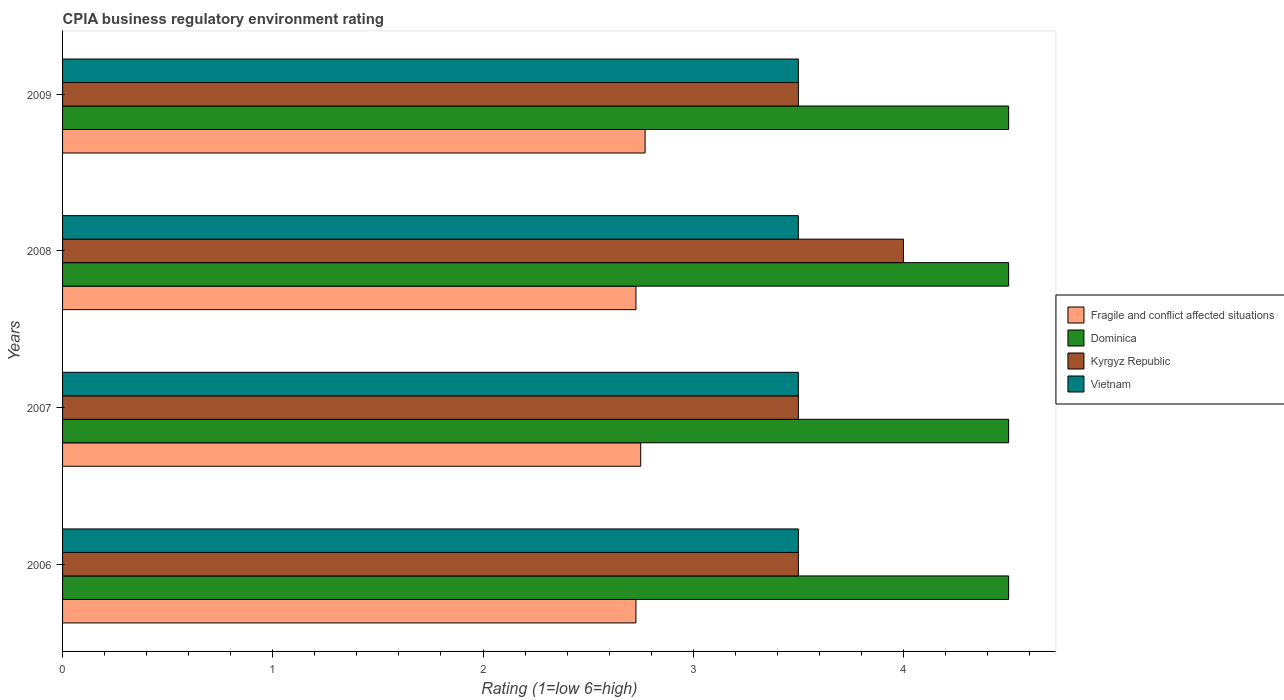How many different coloured bars are there?
Your answer should be compact. 4. Are the number of bars per tick equal to the number of legend labels?
Ensure brevity in your answer.  Yes. In how many cases, is the number of bars for a given year not equal to the number of legend labels?
Offer a terse response. 0. Across all years, what is the maximum CPIA rating in Kyrgyz Republic?
Give a very brief answer. 4. What is the total CPIA rating in Kyrgyz Republic in the graph?
Provide a succinct answer. 14.5. What is the average CPIA rating in Dominica per year?
Give a very brief answer. 4.5. What is the ratio of the CPIA rating in Kyrgyz Republic in 2006 to that in 2008?
Keep it short and to the point. 0.88. Is the CPIA rating in Kyrgyz Republic in 2006 less than that in 2007?
Your answer should be very brief. No. Is the difference between the CPIA rating in Kyrgyz Republic in 2006 and 2009 greater than the difference between the CPIA rating in Dominica in 2006 and 2009?
Keep it short and to the point. No. Is it the case that in every year, the sum of the CPIA rating in Kyrgyz Republic and CPIA rating in Vietnam is greater than the sum of CPIA rating in Dominica and CPIA rating in Fragile and conflict affected situations?
Make the answer very short. No. What does the 4th bar from the top in 2008 represents?
Make the answer very short. Fragile and conflict affected situations. What does the 2nd bar from the bottom in 2008 represents?
Provide a succinct answer. Dominica. How many bars are there?
Provide a short and direct response. 16. Are the values on the major ticks of X-axis written in scientific E-notation?
Provide a short and direct response. No. Does the graph contain any zero values?
Give a very brief answer. No. Does the graph contain grids?
Provide a short and direct response. No. Where does the legend appear in the graph?
Give a very brief answer. Center right. How many legend labels are there?
Offer a very short reply. 4. How are the legend labels stacked?
Ensure brevity in your answer.  Vertical. What is the title of the graph?
Provide a succinct answer. CPIA business regulatory environment rating. What is the label or title of the X-axis?
Give a very brief answer. Rating (1=low 6=high). What is the label or title of the Y-axis?
Keep it short and to the point. Years. What is the Rating (1=low 6=high) in Fragile and conflict affected situations in 2006?
Your answer should be compact. 2.73. What is the Rating (1=low 6=high) in Kyrgyz Republic in 2006?
Your response must be concise. 3.5. What is the Rating (1=low 6=high) in Fragile and conflict affected situations in 2007?
Your response must be concise. 2.75. What is the Rating (1=low 6=high) of Kyrgyz Republic in 2007?
Offer a very short reply. 3.5. What is the Rating (1=low 6=high) of Vietnam in 2007?
Offer a very short reply. 3.5. What is the Rating (1=low 6=high) of Fragile and conflict affected situations in 2008?
Your answer should be compact. 2.73. What is the Rating (1=low 6=high) of Vietnam in 2008?
Provide a short and direct response. 3.5. What is the Rating (1=low 6=high) in Fragile and conflict affected situations in 2009?
Offer a very short reply. 2.77. What is the Rating (1=low 6=high) in Dominica in 2009?
Your response must be concise. 4.5. What is the Rating (1=low 6=high) in Kyrgyz Republic in 2009?
Your response must be concise. 3.5. What is the Rating (1=low 6=high) in Vietnam in 2009?
Provide a short and direct response. 3.5. Across all years, what is the maximum Rating (1=low 6=high) in Fragile and conflict affected situations?
Offer a terse response. 2.77. Across all years, what is the maximum Rating (1=low 6=high) of Vietnam?
Give a very brief answer. 3.5. Across all years, what is the minimum Rating (1=low 6=high) of Fragile and conflict affected situations?
Give a very brief answer. 2.73. Across all years, what is the minimum Rating (1=low 6=high) in Dominica?
Your answer should be compact. 4.5. Across all years, what is the minimum Rating (1=low 6=high) of Kyrgyz Republic?
Provide a short and direct response. 3.5. Across all years, what is the minimum Rating (1=low 6=high) in Vietnam?
Offer a very short reply. 3.5. What is the total Rating (1=low 6=high) in Fragile and conflict affected situations in the graph?
Ensure brevity in your answer.  10.98. What is the total Rating (1=low 6=high) of Kyrgyz Republic in the graph?
Give a very brief answer. 14.5. What is the difference between the Rating (1=low 6=high) of Fragile and conflict affected situations in 2006 and that in 2007?
Your response must be concise. -0.02. What is the difference between the Rating (1=low 6=high) in Fragile and conflict affected situations in 2006 and that in 2008?
Your answer should be very brief. 0. What is the difference between the Rating (1=low 6=high) in Dominica in 2006 and that in 2008?
Your answer should be very brief. 0. What is the difference between the Rating (1=low 6=high) in Fragile and conflict affected situations in 2006 and that in 2009?
Make the answer very short. -0.04. What is the difference between the Rating (1=low 6=high) of Kyrgyz Republic in 2006 and that in 2009?
Offer a terse response. 0. What is the difference between the Rating (1=low 6=high) in Fragile and conflict affected situations in 2007 and that in 2008?
Your response must be concise. 0.02. What is the difference between the Rating (1=low 6=high) of Kyrgyz Republic in 2007 and that in 2008?
Keep it short and to the point. -0.5. What is the difference between the Rating (1=low 6=high) in Vietnam in 2007 and that in 2008?
Your answer should be very brief. 0. What is the difference between the Rating (1=low 6=high) in Fragile and conflict affected situations in 2007 and that in 2009?
Your answer should be compact. -0.02. What is the difference between the Rating (1=low 6=high) in Dominica in 2007 and that in 2009?
Ensure brevity in your answer.  0. What is the difference between the Rating (1=low 6=high) in Fragile and conflict affected situations in 2008 and that in 2009?
Make the answer very short. -0.04. What is the difference between the Rating (1=low 6=high) in Kyrgyz Republic in 2008 and that in 2009?
Provide a short and direct response. 0.5. What is the difference between the Rating (1=low 6=high) of Vietnam in 2008 and that in 2009?
Make the answer very short. 0. What is the difference between the Rating (1=low 6=high) of Fragile and conflict affected situations in 2006 and the Rating (1=low 6=high) of Dominica in 2007?
Give a very brief answer. -1.77. What is the difference between the Rating (1=low 6=high) of Fragile and conflict affected situations in 2006 and the Rating (1=low 6=high) of Kyrgyz Republic in 2007?
Your answer should be very brief. -0.77. What is the difference between the Rating (1=low 6=high) in Fragile and conflict affected situations in 2006 and the Rating (1=low 6=high) in Vietnam in 2007?
Offer a terse response. -0.77. What is the difference between the Rating (1=low 6=high) in Dominica in 2006 and the Rating (1=low 6=high) in Kyrgyz Republic in 2007?
Provide a succinct answer. 1. What is the difference between the Rating (1=low 6=high) in Dominica in 2006 and the Rating (1=low 6=high) in Vietnam in 2007?
Offer a very short reply. 1. What is the difference between the Rating (1=low 6=high) of Kyrgyz Republic in 2006 and the Rating (1=low 6=high) of Vietnam in 2007?
Your answer should be compact. 0. What is the difference between the Rating (1=low 6=high) in Fragile and conflict affected situations in 2006 and the Rating (1=low 6=high) in Dominica in 2008?
Ensure brevity in your answer.  -1.77. What is the difference between the Rating (1=low 6=high) of Fragile and conflict affected situations in 2006 and the Rating (1=low 6=high) of Kyrgyz Republic in 2008?
Ensure brevity in your answer.  -1.27. What is the difference between the Rating (1=low 6=high) of Fragile and conflict affected situations in 2006 and the Rating (1=low 6=high) of Vietnam in 2008?
Your answer should be very brief. -0.77. What is the difference between the Rating (1=low 6=high) in Dominica in 2006 and the Rating (1=low 6=high) in Kyrgyz Republic in 2008?
Provide a succinct answer. 0.5. What is the difference between the Rating (1=low 6=high) in Dominica in 2006 and the Rating (1=low 6=high) in Vietnam in 2008?
Ensure brevity in your answer.  1. What is the difference between the Rating (1=low 6=high) of Kyrgyz Republic in 2006 and the Rating (1=low 6=high) of Vietnam in 2008?
Make the answer very short. 0. What is the difference between the Rating (1=low 6=high) in Fragile and conflict affected situations in 2006 and the Rating (1=low 6=high) in Dominica in 2009?
Provide a succinct answer. -1.77. What is the difference between the Rating (1=low 6=high) in Fragile and conflict affected situations in 2006 and the Rating (1=low 6=high) in Kyrgyz Republic in 2009?
Your answer should be compact. -0.77. What is the difference between the Rating (1=low 6=high) in Fragile and conflict affected situations in 2006 and the Rating (1=low 6=high) in Vietnam in 2009?
Offer a very short reply. -0.77. What is the difference between the Rating (1=low 6=high) in Dominica in 2006 and the Rating (1=low 6=high) in Kyrgyz Republic in 2009?
Make the answer very short. 1. What is the difference between the Rating (1=low 6=high) of Fragile and conflict affected situations in 2007 and the Rating (1=low 6=high) of Dominica in 2008?
Your answer should be very brief. -1.75. What is the difference between the Rating (1=low 6=high) in Fragile and conflict affected situations in 2007 and the Rating (1=low 6=high) in Kyrgyz Republic in 2008?
Make the answer very short. -1.25. What is the difference between the Rating (1=low 6=high) in Fragile and conflict affected situations in 2007 and the Rating (1=low 6=high) in Vietnam in 2008?
Your response must be concise. -0.75. What is the difference between the Rating (1=low 6=high) of Dominica in 2007 and the Rating (1=low 6=high) of Vietnam in 2008?
Your response must be concise. 1. What is the difference between the Rating (1=low 6=high) of Kyrgyz Republic in 2007 and the Rating (1=low 6=high) of Vietnam in 2008?
Offer a terse response. 0. What is the difference between the Rating (1=low 6=high) of Fragile and conflict affected situations in 2007 and the Rating (1=low 6=high) of Dominica in 2009?
Your answer should be very brief. -1.75. What is the difference between the Rating (1=low 6=high) in Fragile and conflict affected situations in 2007 and the Rating (1=low 6=high) in Kyrgyz Republic in 2009?
Make the answer very short. -0.75. What is the difference between the Rating (1=low 6=high) in Fragile and conflict affected situations in 2007 and the Rating (1=low 6=high) in Vietnam in 2009?
Keep it short and to the point. -0.75. What is the difference between the Rating (1=low 6=high) in Dominica in 2007 and the Rating (1=low 6=high) in Vietnam in 2009?
Your answer should be compact. 1. What is the difference between the Rating (1=low 6=high) in Kyrgyz Republic in 2007 and the Rating (1=low 6=high) in Vietnam in 2009?
Offer a very short reply. 0. What is the difference between the Rating (1=low 6=high) of Fragile and conflict affected situations in 2008 and the Rating (1=low 6=high) of Dominica in 2009?
Ensure brevity in your answer.  -1.77. What is the difference between the Rating (1=low 6=high) in Fragile and conflict affected situations in 2008 and the Rating (1=low 6=high) in Kyrgyz Republic in 2009?
Your response must be concise. -0.77. What is the difference between the Rating (1=low 6=high) of Fragile and conflict affected situations in 2008 and the Rating (1=low 6=high) of Vietnam in 2009?
Keep it short and to the point. -0.77. What is the difference between the Rating (1=low 6=high) in Kyrgyz Republic in 2008 and the Rating (1=low 6=high) in Vietnam in 2009?
Your answer should be compact. 0.5. What is the average Rating (1=low 6=high) of Fragile and conflict affected situations per year?
Keep it short and to the point. 2.74. What is the average Rating (1=low 6=high) of Kyrgyz Republic per year?
Ensure brevity in your answer.  3.62. In the year 2006, what is the difference between the Rating (1=low 6=high) in Fragile and conflict affected situations and Rating (1=low 6=high) in Dominica?
Offer a terse response. -1.77. In the year 2006, what is the difference between the Rating (1=low 6=high) of Fragile and conflict affected situations and Rating (1=low 6=high) of Kyrgyz Republic?
Offer a very short reply. -0.77. In the year 2006, what is the difference between the Rating (1=low 6=high) in Fragile and conflict affected situations and Rating (1=low 6=high) in Vietnam?
Make the answer very short. -0.77. In the year 2006, what is the difference between the Rating (1=low 6=high) in Dominica and Rating (1=low 6=high) in Vietnam?
Offer a terse response. 1. In the year 2006, what is the difference between the Rating (1=low 6=high) of Kyrgyz Republic and Rating (1=low 6=high) of Vietnam?
Your response must be concise. 0. In the year 2007, what is the difference between the Rating (1=low 6=high) in Fragile and conflict affected situations and Rating (1=low 6=high) in Dominica?
Offer a terse response. -1.75. In the year 2007, what is the difference between the Rating (1=low 6=high) of Fragile and conflict affected situations and Rating (1=low 6=high) of Kyrgyz Republic?
Give a very brief answer. -0.75. In the year 2007, what is the difference between the Rating (1=low 6=high) in Fragile and conflict affected situations and Rating (1=low 6=high) in Vietnam?
Ensure brevity in your answer.  -0.75. In the year 2007, what is the difference between the Rating (1=low 6=high) of Dominica and Rating (1=low 6=high) of Kyrgyz Republic?
Provide a short and direct response. 1. In the year 2008, what is the difference between the Rating (1=low 6=high) of Fragile and conflict affected situations and Rating (1=low 6=high) of Dominica?
Offer a very short reply. -1.77. In the year 2008, what is the difference between the Rating (1=low 6=high) of Fragile and conflict affected situations and Rating (1=low 6=high) of Kyrgyz Republic?
Your answer should be compact. -1.27. In the year 2008, what is the difference between the Rating (1=low 6=high) in Fragile and conflict affected situations and Rating (1=low 6=high) in Vietnam?
Offer a terse response. -0.77. In the year 2008, what is the difference between the Rating (1=low 6=high) in Dominica and Rating (1=low 6=high) in Kyrgyz Republic?
Your answer should be very brief. 0.5. In the year 2009, what is the difference between the Rating (1=low 6=high) of Fragile and conflict affected situations and Rating (1=low 6=high) of Dominica?
Make the answer very short. -1.73. In the year 2009, what is the difference between the Rating (1=low 6=high) in Fragile and conflict affected situations and Rating (1=low 6=high) in Kyrgyz Republic?
Make the answer very short. -0.73. In the year 2009, what is the difference between the Rating (1=low 6=high) of Fragile and conflict affected situations and Rating (1=low 6=high) of Vietnam?
Provide a succinct answer. -0.73. In the year 2009, what is the difference between the Rating (1=low 6=high) of Dominica and Rating (1=low 6=high) of Kyrgyz Republic?
Provide a succinct answer. 1. In the year 2009, what is the difference between the Rating (1=low 6=high) of Kyrgyz Republic and Rating (1=low 6=high) of Vietnam?
Your answer should be compact. 0. What is the ratio of the Rating (1=low 6=high) of Kyrgyz Republic in 2006 to that in 2007?
Ensure brevity in your answer.  1. What is the ratio of the Rating (1=low 6=high) in Dominica in 2006 to that in 2008?
Provide a short and direct response. 1. What is the ratio of the Rating (1=low 6=high) in Kyrgyz Republic in 2006 to that in 2008?
Offer a terse response. 0.88. What is the ratio of the Rating (1=low 6=high) of Vietnam in 2006 to that in 2008?
Keep it short and to the point. 1. What is the ratio of the Rating (1=low 6=high) of Fragile and conflict affected situations in 2006 to that in 2009?
Give a very brief answer. 0.98. What is the ratio of the Rating (1=low 6=high) in Dominica in 2006 to that in 2009?
Your response must be concise. 1. What is the ratio of the Rating (1=low 6=high) of Kyrgyz Republic in 2006 to that in 2009?
Keep it short and to the point. 1. What is the ratio of the Rating (1=low 6=high) of Vietnam in 2006 to that in 2009?
Ensure brevity in your answer.  1. What is the ratio of the Rating (1=low 6=high) in Fragile and conflict affected situations in 2007 to that in 2008?
Offer a terse response. 1.01. What is the ratio of the Rating (1=low 6=high) of Kyrgyz Republic in 2007 to that in 2008?
Provide a succinct answer. 0.88. What is the ratio of the Rating (1=low 6=high) in Fragile and conflict affected situations in 2007 to that in 2009?
Offer a terse response. 0.99. What is the ratio of the Rating (1=low 6=high) in Dominica in 2007 to that in 2009?
Your response must be concise. 1. What is the ratio of the Rating (1=low 6=high) in Kyrgyz Republic in 2007 to that in 2009?
Your answer should be very brief. 1. What is the ratio of the Rating (1=low 6=high) of Vietnam in 2007 to that in 2009?
Make the answer very short. 1. What is the ratio of the Rating (1=low 6=high) of Fragile and conflict affected situations in 2008 to that in 2009?
Provide a short and direct response. 0.98. What is the ratio of the Rating (1=low 6=high) in Dominica in 2008 to that in 2009?
Give a very brief answer. 1. What is the ratio of the Rating (1=low 6=high) of Kyrgyz Republic in 2008 to that in 2009?
Keep it short and to the point. 1.14. What is the difference between the highest and the second highest Rating (1=low 6=high) of Fragile and conflict affected situations?
Keep it short and to the point. 0.02. What is the difference between the highest and the second highest Rating (1=low 6=high) in Dominica?
Make the answer very short. 0. What is the difference between the highest and the second highest Rating (1=low 6=high) in Vietnam?
Offer a very short reply. 0. What is the difference between the highest and the lowest Rating (1=low 6=high) of Fragile and conflict affected situations?
Offer a terse response. 0.04. What is the difference between the highest and the lowest Rating (1=low 6=high) in Dominica?
Your response must be concise. 0. 